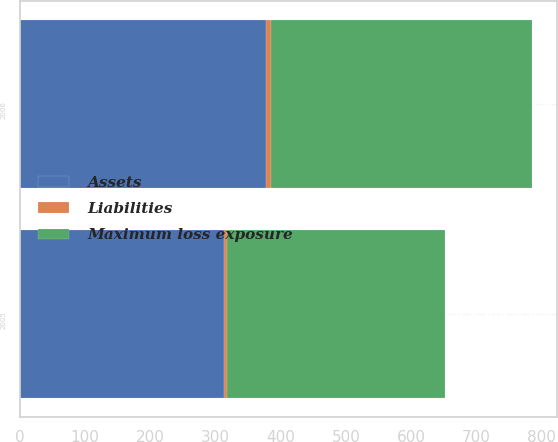<chart> <loc_0><loc_0><loc_500><loc_500><stacked_bar_chart><ecel><fcel>2006<fcel>2005<nl><fcel>Maximum loss exposure<fcel>400<fcel>335<nl><fcel>Assets<fcel>378<fcel>313<nl><fcel>Liabilities<fcel>7<fcel>4<nl></chart> 